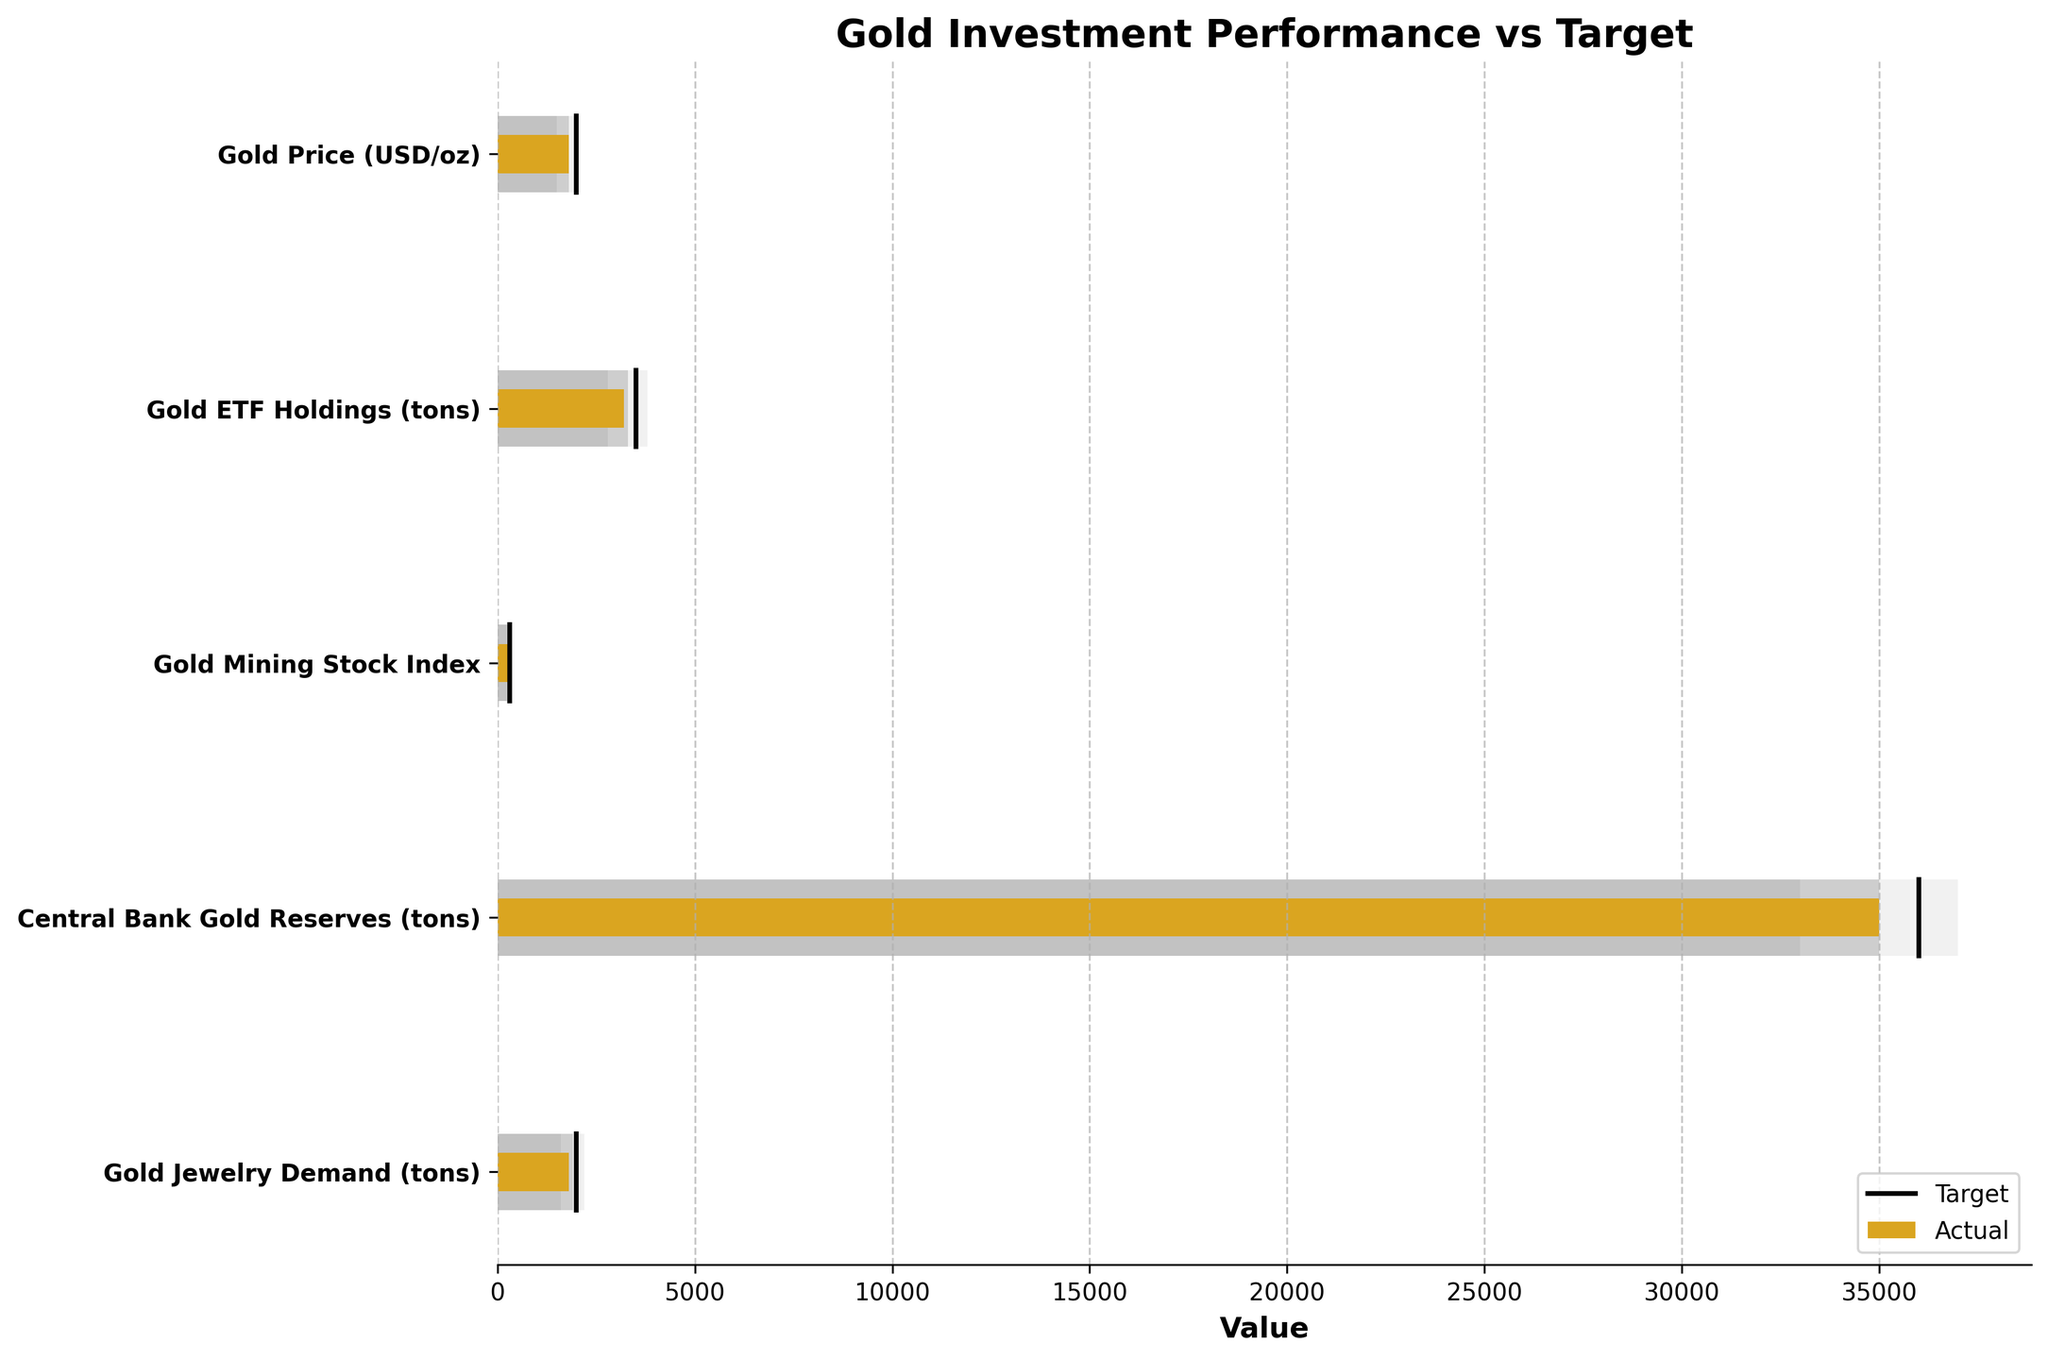What is the actual value of the Gold Price (USD/oz)? The actual value can be read directly from the bar labeled "Gold Price (USD/oz)" which has a bar colored in goldenrod.
Answer: 1810 What is the target value for Central Bank Gold Reserves (tons)? The target value is represented by a black line across the bar labeled "Central Bank Gold Reserves (tons)".
Answer: 36000 How does the actual value of Gold ETF Holdings (tons) compare to its target? The actual value, represented by the bar, is at 3200, while the target value, shown by the black line, is at 3500. Therefore, the actual value is below the target.
Answer: Below target Are the actual values for any of the categories equal to their target values? By comparing the length of the goldenrod bars to their corresponding black lines, none of the bars match the target exactly.
Answer: No Which category has the closest actual value to its target value? By visual inspection, the bar for "Gold Price (USD/oz)" appears closest to its target (1810 vs. 2000).
Answer: Gold Price (USD/oz) What is the difference between actual and target values for Gold Mining Stock Index? The actual value is 280 and the target is 300. The difference is 300 - 280.
Answer: 20 Which category has the largest deviation from its target value? Comparing all bars, the "Gold ETF Holdings (tons)" has an actual value of 3200 and a target of 3500, a difference of 300 which is the largest deviation.
Answer: Gold ETF Holdings (tons) What are the value ranges for Gold Jewelry Demand (tons)? The ranges are represented by different shades of gray bars. Range1 is 1600, Range2 is 1900, and Range3 is 2200.
Answer: 1600, 1900, 2200 If the actual value of Gold Jewelry Demand (tons) were to increase by 250 tons, would it surpass the target? The current actual value is 1800. Increasing this by 250 results in 2050, which is greater than the target value of 2000.
Answer: Yes, it would surpass the target In which value range does the actual Central Bank Gold Reserves (tons) fall? The actual value of 35000 falls in the second range (Range2) which spans from 35000 to 37000.
Answer: Range2 